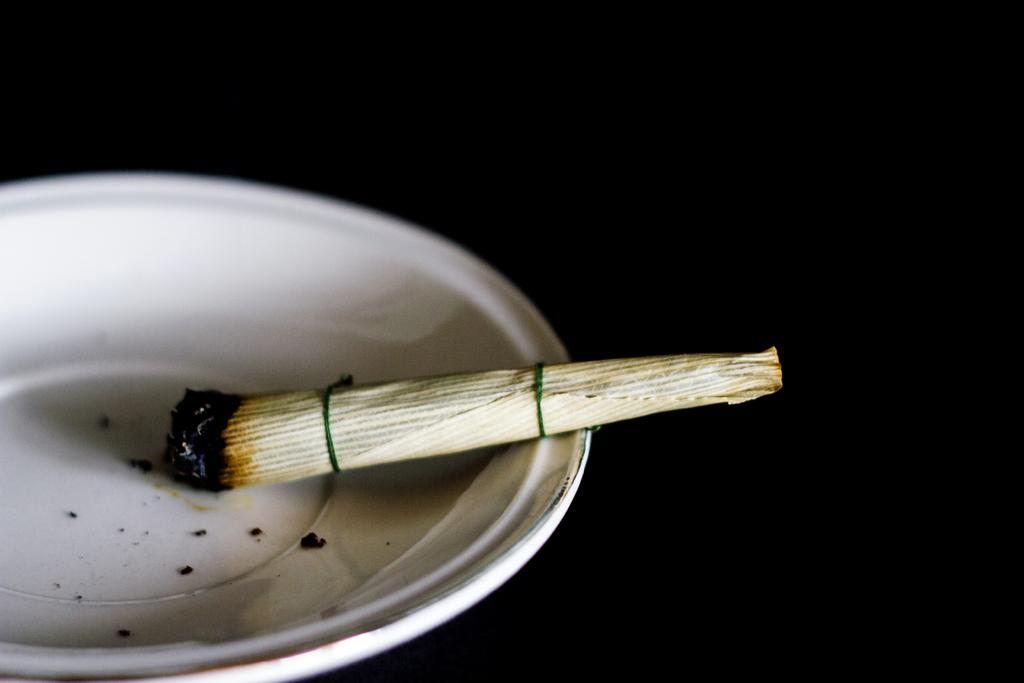What is placed in the bowl in the image? There is a cigarette placed in a bowl. Can you describe the background of the image? The background of the image is dark. What type of thrill can be seen running along the dock in the image? There is no dock or thrill present in the image; it only features a cigarette placed in a bowl with a dark background. 